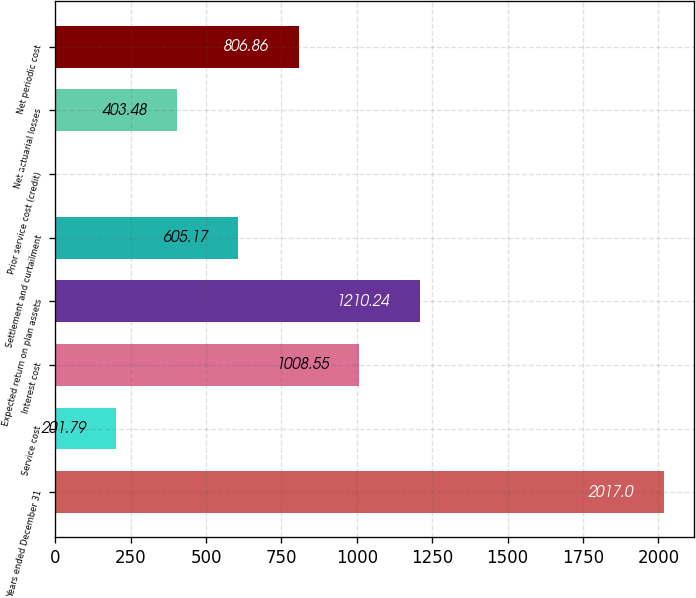<chart> <loc_0><loc_0><loc_500><loc_500><bar_chart><fcel>Years ended December 31<fcel>Service cost<fcel>Interest cost<fcel>Expected return on plan assets<fcel>Settlement and curtailment<fcel>Prior service cost (credit)<fcel>Net actuarial losses<fcel>Net periodic cost<nl><fcel>2017<fcel>201.79<fcel>1008.55<fcel>1210.24<fcel>605.17<fcel>0.1<fcel>403.48<fcel>806.86<nl></chart> 